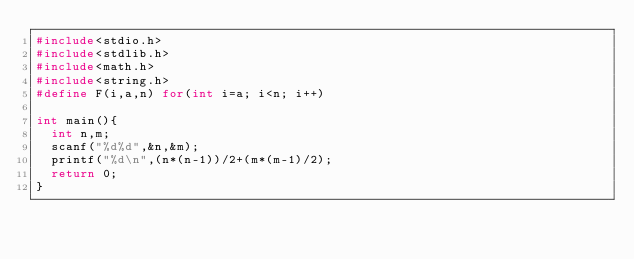Convert code to text. <code><loc_0><loc_0><loc_500><loc_500><_C_>#include<stdio.h>
#include<stdlib.h>
#include<math.h>
#include<string.h>
#define F(i,a,n) for(int i=a; i<n; i++)

int main(){
  int n,m;
  scanf("%d%d",&n,&m);
  printf("%d\n",(n*(n-1))/2+(m*(m-1)/2);
  return 0;
}</code> 